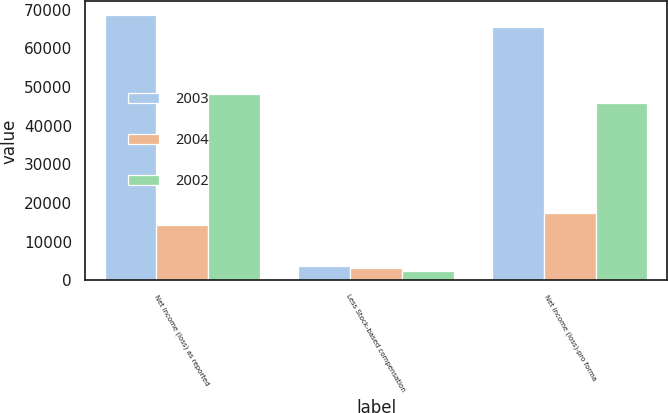<chart> <loc_0><loc_0><loc_500><loc_500><stacked_bar_chart><ecel><fcel>Net income (loss) as reported<fcel>Less Stock-based compensation<fcel>Net income (loss)-pro forma<nl><fcel>2003<fcel>68730<fcel>3583<fcel>65558<nl><fcel>2004<fcel>14358<fcel>3194<fcel>17429<nl><fcel>2002<fcel>48179<fcel>2315<fcel>45864<nl></chart> 